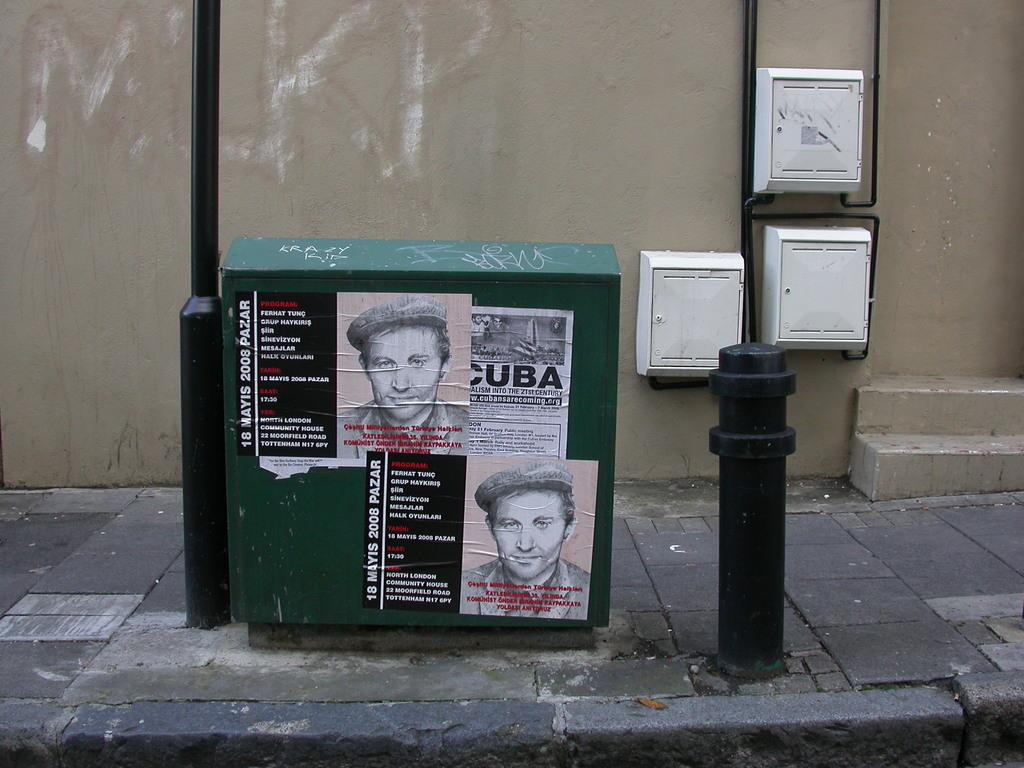What is the green object in the image with posters attached to it? There are posters attached to a green box in the image. What can be seen on the right side of the image? There is a pole on the right side of the image. What type of structure is visible in the image? There is a wall in the image. How does the impulse affect the dirt in the image? There is no impulse or dirt present in the image. What type of hall is visible in the image? There is no hall present in the image. 